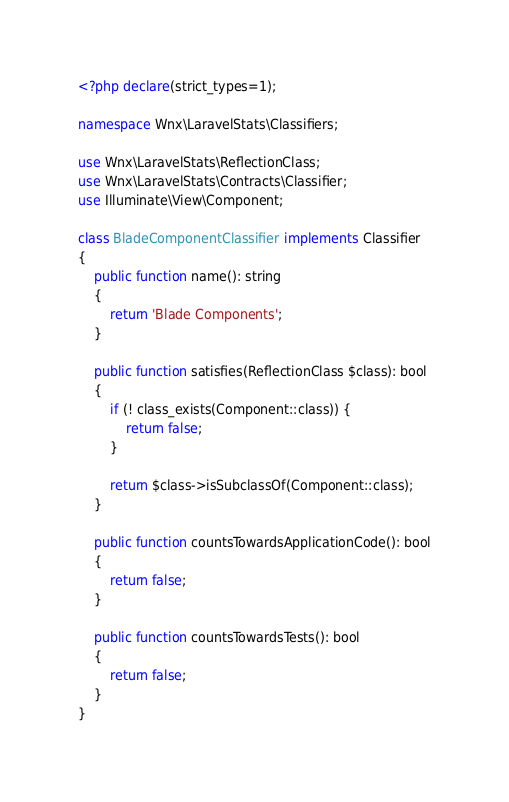<code> <loc_0><loc_0><loc_500><loc_500><_PHP_><?php declare(strict_types=1);

namespace Wnx\LaravelStats\Classifiers;

use Wnx\LaravelStats\ReflectionClass;
use Wnx\LaravelStats\Contracts\Classifier;
use Illuminate\View\Component;

class BladeComponentClassifier implements Classifier
{
    public function name(): string
    {
        return 'Blade Components';
    }

    public function satisfies(ReflectionClass $class): bool
    {
        if (! class_exists(Component::class)) {
            return false;
        }

        return $class->isSubclassOf(Component::class);
    }

    public function countsTowardsApplicationCode(): bool
    {
        return false;
    }

    public function countsTowardsTests(): bool
    {
        return false;
    }
}
</code> 